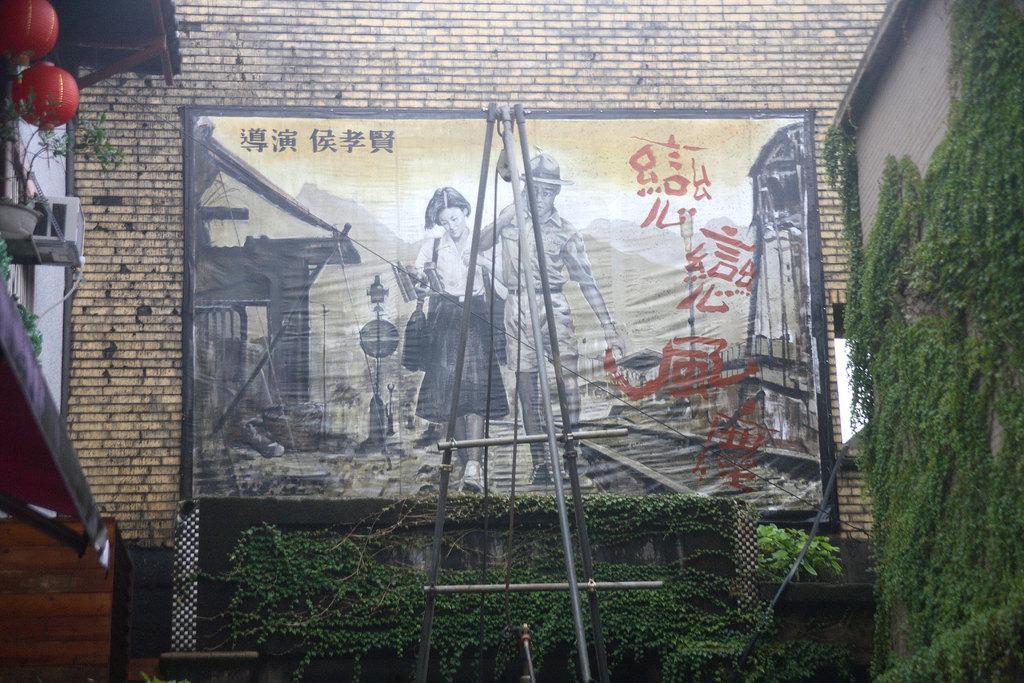In one or two sentences, can you explain what this image depicts? In this picture I can see buildings and a picture on the wall and I can see few plants and few metal rods with a pulley and I can see couple of lanterns hanging on the left side and I can see a plant in the pot. 